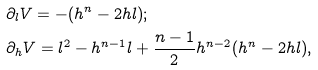Convert formula to latex. <formula><loc_0><loc_0><loc_500><loc_500>& \partial _ { l } V = - ( h ^ { n } - 2 h l ) ; \\ & \partial _ { h } V = l ^ { 2 } - h ^ { n - 1 } l + \frac { n - 1 } { 2 } h ^ { n - 2 } ( h ^ { n } - 2 h l ) ,</formula> 